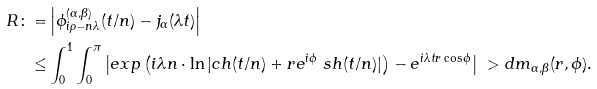<formula> <loc_0><loc_0><loc_500><loc_500>R \colon = & \left | \phi _ { i \rho - n \lambda } ^ { ( \alpha , \beta ) } ( t / n ) - j _ { \alpha } ( \lambda t ) \right | \\ \leq & \int _ { 0 } ^ { 1 } \int _ { 0 } ^ { \pi } \left | e x p \left ( i \lambda n \cdot \ln | c h ( t / n ) + r e ^ { i \phi } \ s h ( t / n ) | \right ) - e ^ { i \lambda t r \cos \phi } \right | \ > d m _ { \alpha , \beta } ( r , \phi ) .</formula> 